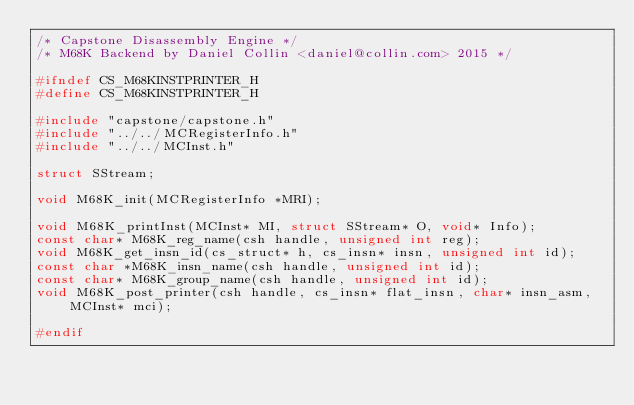<code> <loc_0><loc_0><loc_500><loc_500><_C_>/* Capstone Disassembly Engine */
/* M68K Backend by Daniel Collin <daniel@collin.com> 2015 */

#ifndef CS_M68KINSTPRINTER_H
#define CS_M68KINSTPRINTER_H

#include "capstone/capstone.h"
#include "../../MCRegisterInfo.h"
#include "../../MCInst.h"

struct SStream;

void M68K_init(MCRegisterInfo *MRI);

void M68K_printInst(MCInst* MI, struct SStream* O, void* Info);
const char* M68K_reg_name(csh handle, unsigned int reg);
void M68K_get_insn_id(cs_struct* h, cs_insn* insn, unsigned int id);
const char *M68K_insn_name(csh handle, unsigned int id);
const char* M68K_group_name(csh handle, unsigned int id);
void M68K_post_printer(csh handle, cs_insn* flat_insn, char* insn_asm, MCInst* mci);

#endif

</code> 